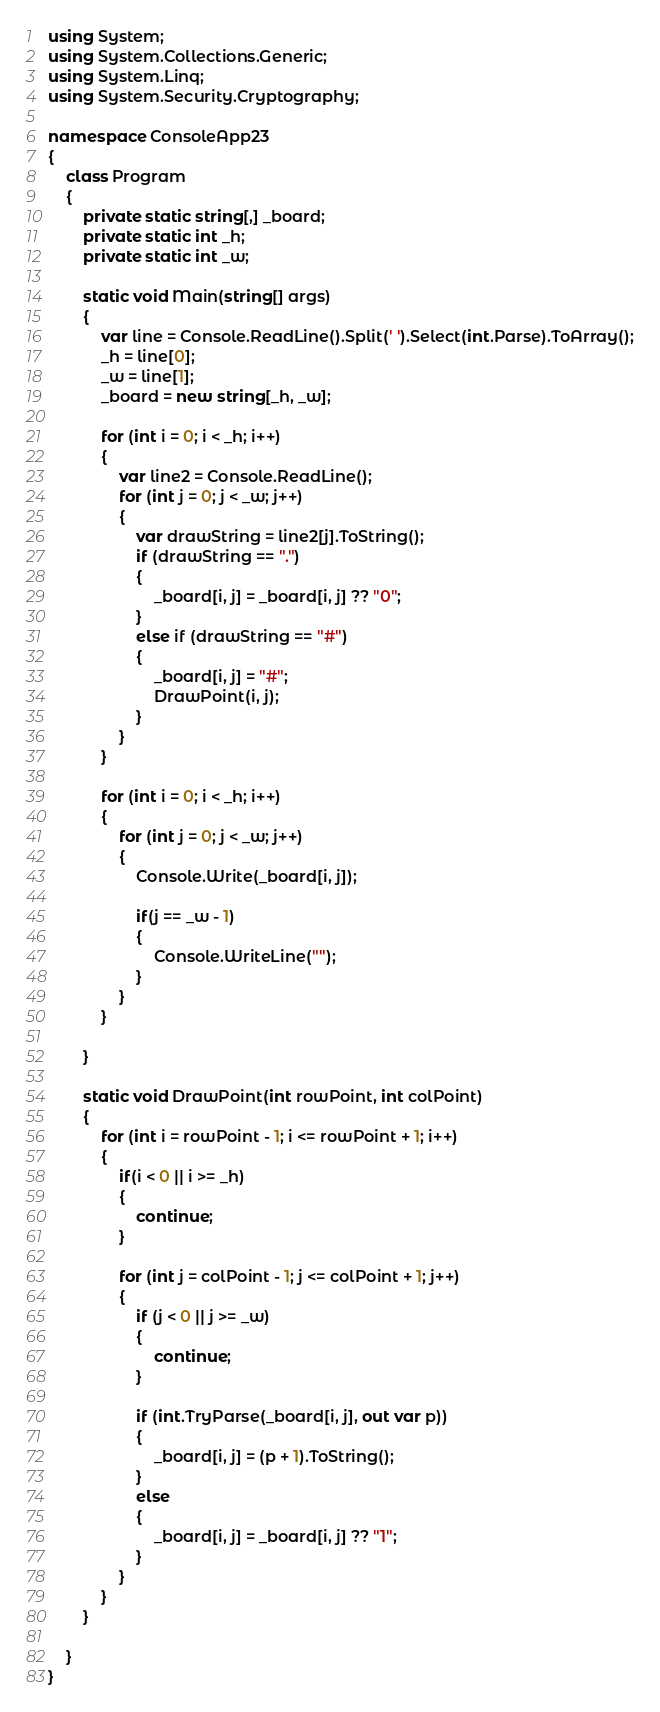Convert code to text. <code><loc_0><loc_0><loc_500><loc_500><_C#_>using System;
using System.Collections.Generic;
using System.Linq;
using System.Security.Cryptography;

namespace ConsoleApp23
{
    class Program
    {
        private static string[,] _board;
        private static int _h;
        private static int _w;

        static void Main(string[] args)
        {
            var line = Console.ReadLine().Split(' ').Select(int.Parse).ToArray();
            _h = line[0];
            _w = line[1];
            _board = new string[_h, _w];

            for (int i = 0; i < _h; i++)
            {
                var line2 = Console.ReadLine();
                for (int j = 0; j < _w; j++)
                {
                    var drawString = line2[j].ToString();
                    if (drawString == ".")
                    {
                        _board[i, j] = _board[i, j] ?? "0";
                    }
                    else if (drawString == "#")
                    {
                        _board[i, j] = "#";
                        DrawPoint(i, j);
                    }
                }
            }

            for (int i = 0; i < _h; i++)
            {
                for (int j = 0; j < _w; j++)
                {
                    Console.Write(_board[i, j]);

                    if(j == _w - 1)
                    {
                        Console.WriteLine("");
                    }
                }
            }

        }

        static void DrawPoint(int rowPoint, int colPoint)
        {
            for (int i = rowPoint - 1; i <= rowPoint + 1; i++)
            {
                if(i < 0 || i >= _h)
                {
                    continue;
                }

                for (int j = colPoint - 1; j <= colPoint + 1; j++)
                {
                    if (j < 0 || j >= _w)
                    {
                        continue;
                    }

                    if (int.TryParse(_board[i, j], out var p))
                    {
                        _board[i, j] = (p + 1).ToString();
                    }
                    else
                    {
                        _board[i, j] = _board[i, j] ?? "1";
                    }
                }
            }
        }

    }
}
</code> 